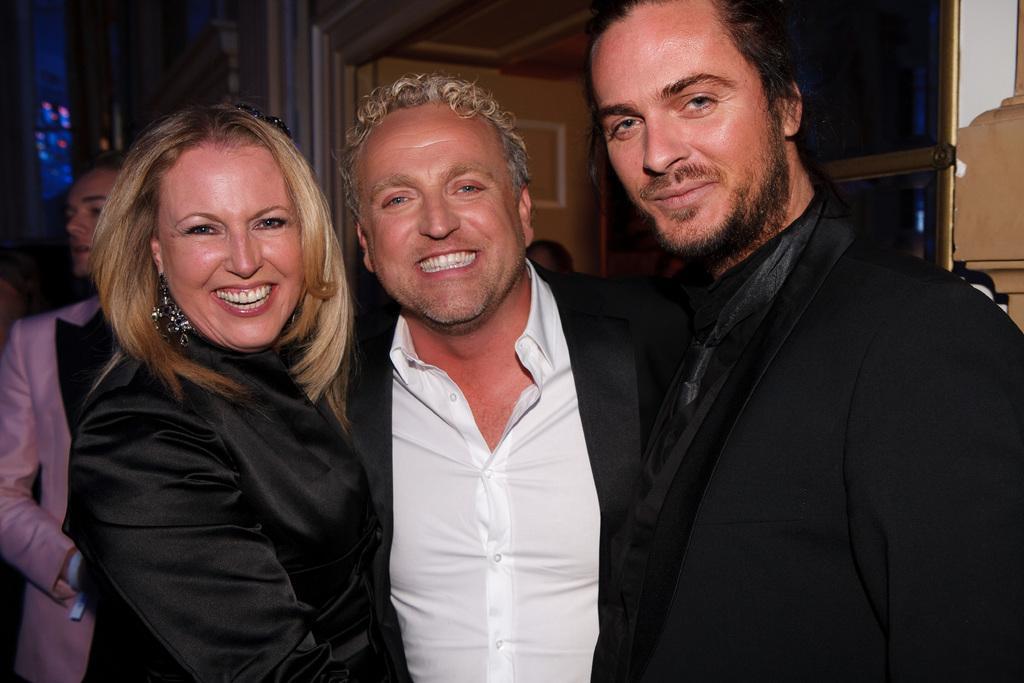Could you give a brief overview of what you see in this image? In this image I can see two men wearing black colored blazers and a woman wearing black colored dress are standing and smiling. In the background I can see the door, the wall and a person wearing pink colored dress is standing to the left side of the image. 